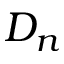<formula> <loc_0><loc_0><loc_500><loc_500>D _ { n }</formula> 